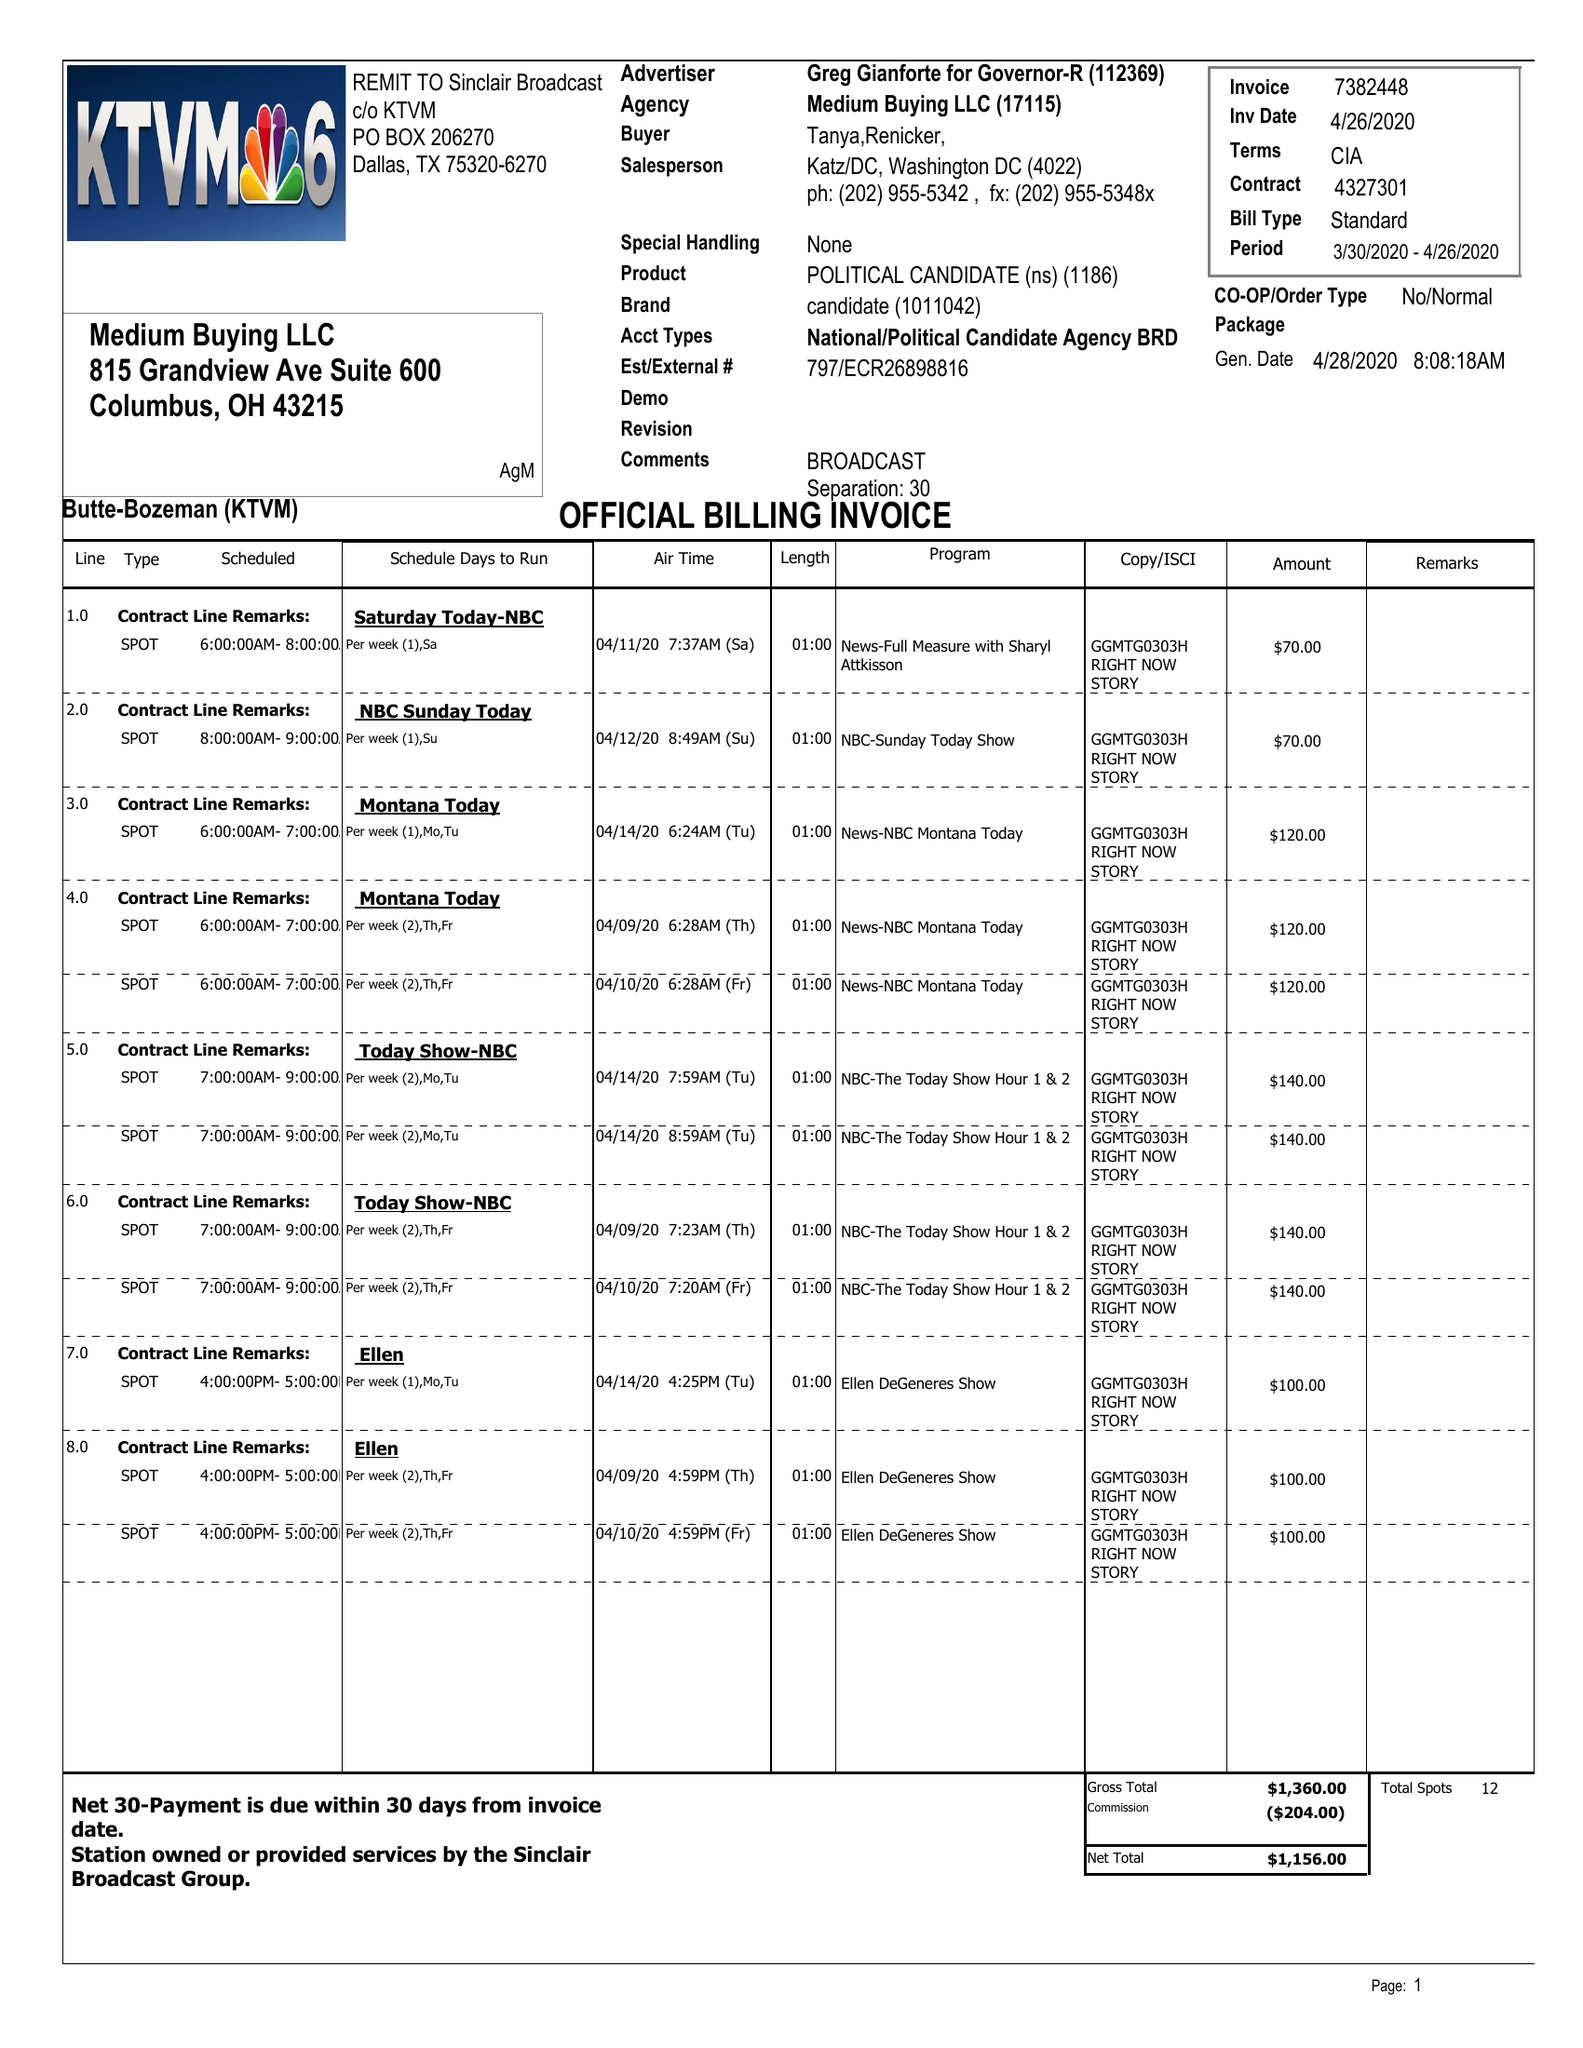What is the value for the flight_from?
Answer the question using a single word or phrase. 03/30/20 